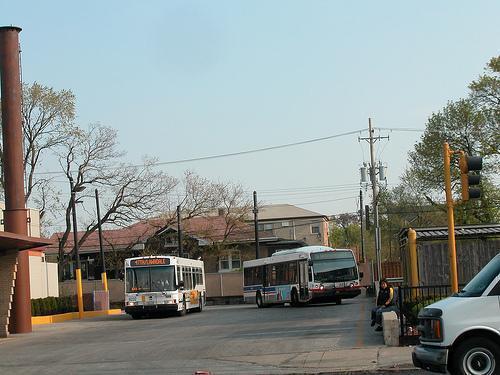How many buses?
Give a very brief answer. 2. 